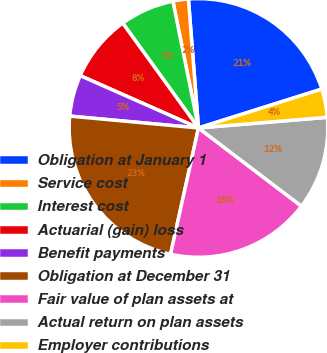Convert chart. <chart><loc_0><loc_0><loc_500><loc_500><pie_chart><fcel>Obligation at January 1<fcel>Service cost<fcel>Interest cost<fcel>Actuarial (gain) loss<fcel>Benefit payments<fcel>Obligation at December 31<fcel>Fair value of plan assets at<fcel>Actual return on plan assets<fcel>Employer contributions<nl><fcel>21.38%<fcel>1.93%<fcel>6.79%<fcel>8.41%<fcel>5.17%<fcel>23.0%<fcel>18.13%<fcel>11.65%<fcel>3.55%<nl></chart> 